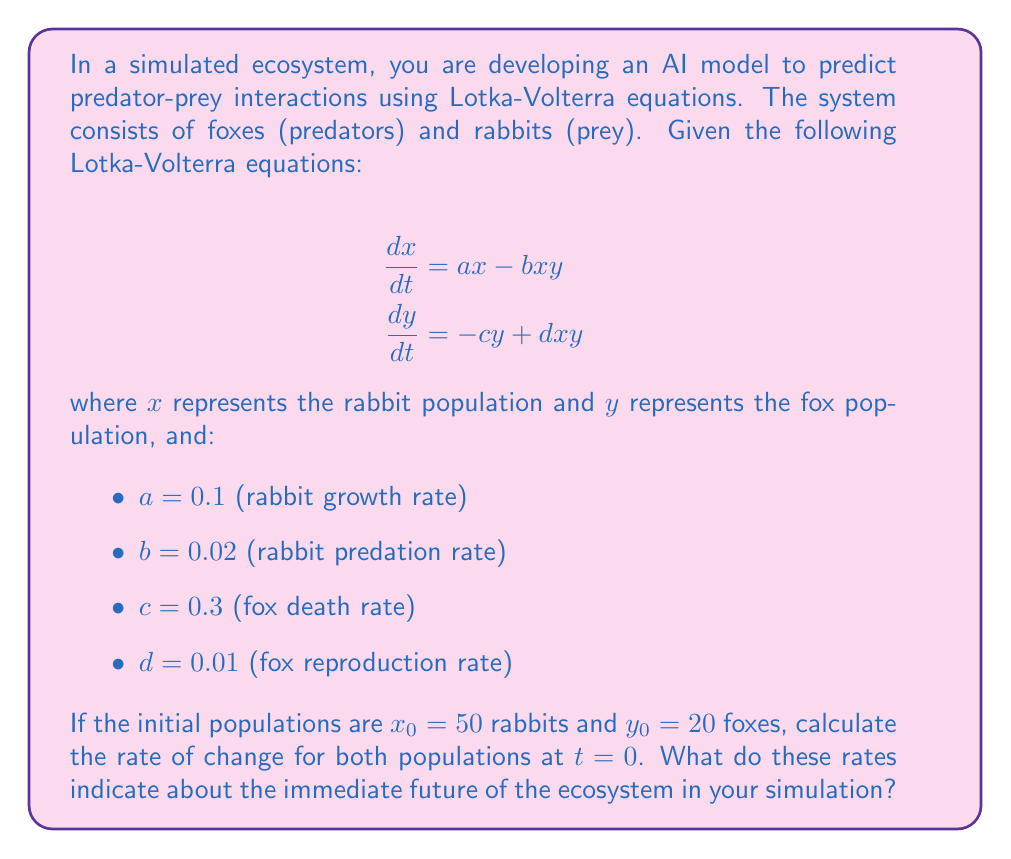Can you solve this math problem? To solve this problem, we need to use the given Lotka-Volterra equations and substitute the known values. Let's approach this step-by-step:

1. For the rabbit population (x):
   $$\frac{dx}{dt} = ax - bxy$$
   
   Substituting the values:
   $$\frac{dx}{dt} = 0.1x - 0.02xy$$
   
   At t = 0, x = 50 and y = 20:
   $$\frac{dx}{dt} = 0.1(50) - 0.02(50)(20)$$
   $$\frac{dx}{dt} = 5 - 20 = -15$$

2. For the fox population (y):
   $$\frac{dy}{dt} = -cy + dxy$$
   
   Substituting the values:
   $$\frac{dy}{dt} = -0.3y + 0.01xy$$
   
   At t = 0, x = 50 and y = 20:
   $$\frac{dy}{dt} = -0.3(20) + 0.01(50)(20)$$
   $$\frac{dy}{dt} = -6 + 10 = 4$$

Interpretation:
- The negative rate of change for rabbits (-15) indicates that the rabbit population is decreasing at t = 0. This is because the current fox population is high enough to cause a net decrease in rabbits, despite their natural growth rate.
- The positive rate of change for foxes (4) indicates that the fox population is increasing at t = 0. This is because there are enough rabbits to support fox reproduction, overcoming their natural death rate.

In the immediate future of the simulation:
1. The rabbit population will decrease rapidly.
2. The fox population will increase.
3. As the rabbit population decreases, it will eventually lead to a decrease in the fox population due to lack of food.
4. This cycle will continue, potentially leading to oscillations in both populations over time, which is a characteristic behavior of Lotka-Volterra systems.

These initial rates provide valuable information for your AI model to predict the short-term dynamics of the ecosystem in the simulation.
Answer: At t = 0:
Rate of change for rabbits: $\frac{dx}{dt} = -15$
Rate of change for foxes: $\frac{dy}{dt} = 4$

These rates indicate an immediate decrease in the rabbit population and an increase in the fox population, suggesting a period of predator success and prey decline in the simulated ecosystem. 